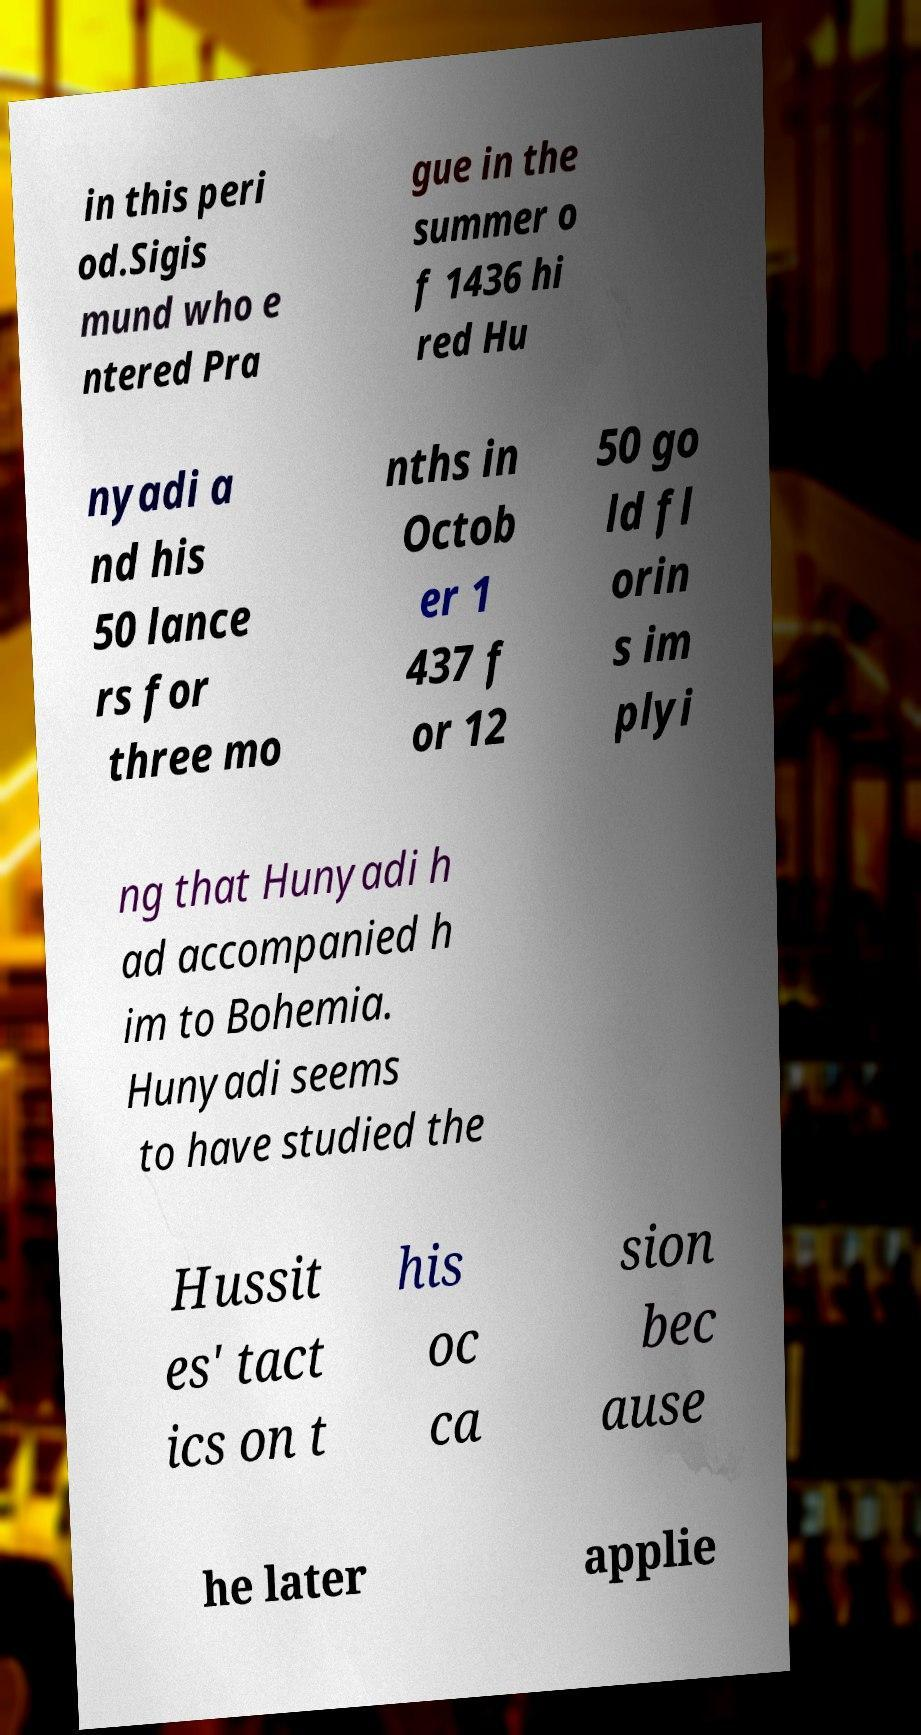What messages or text are displayed in this image? I need them in a readable, typed format. in this peri od.Sigis mund who e ntered Pra gue in the summer o f 1436 hi red Hu nyadi a nd his 50 lance rs for three mo nths in Octob er 1 437 f or 12 50 go ld fl orin s im plyi ng that Hunyadi h ad accompanied h im to Bohemia. Hunyadi seems to have studied the Hussit es' tact ics on t his oc ca sion bec ause he later applie 